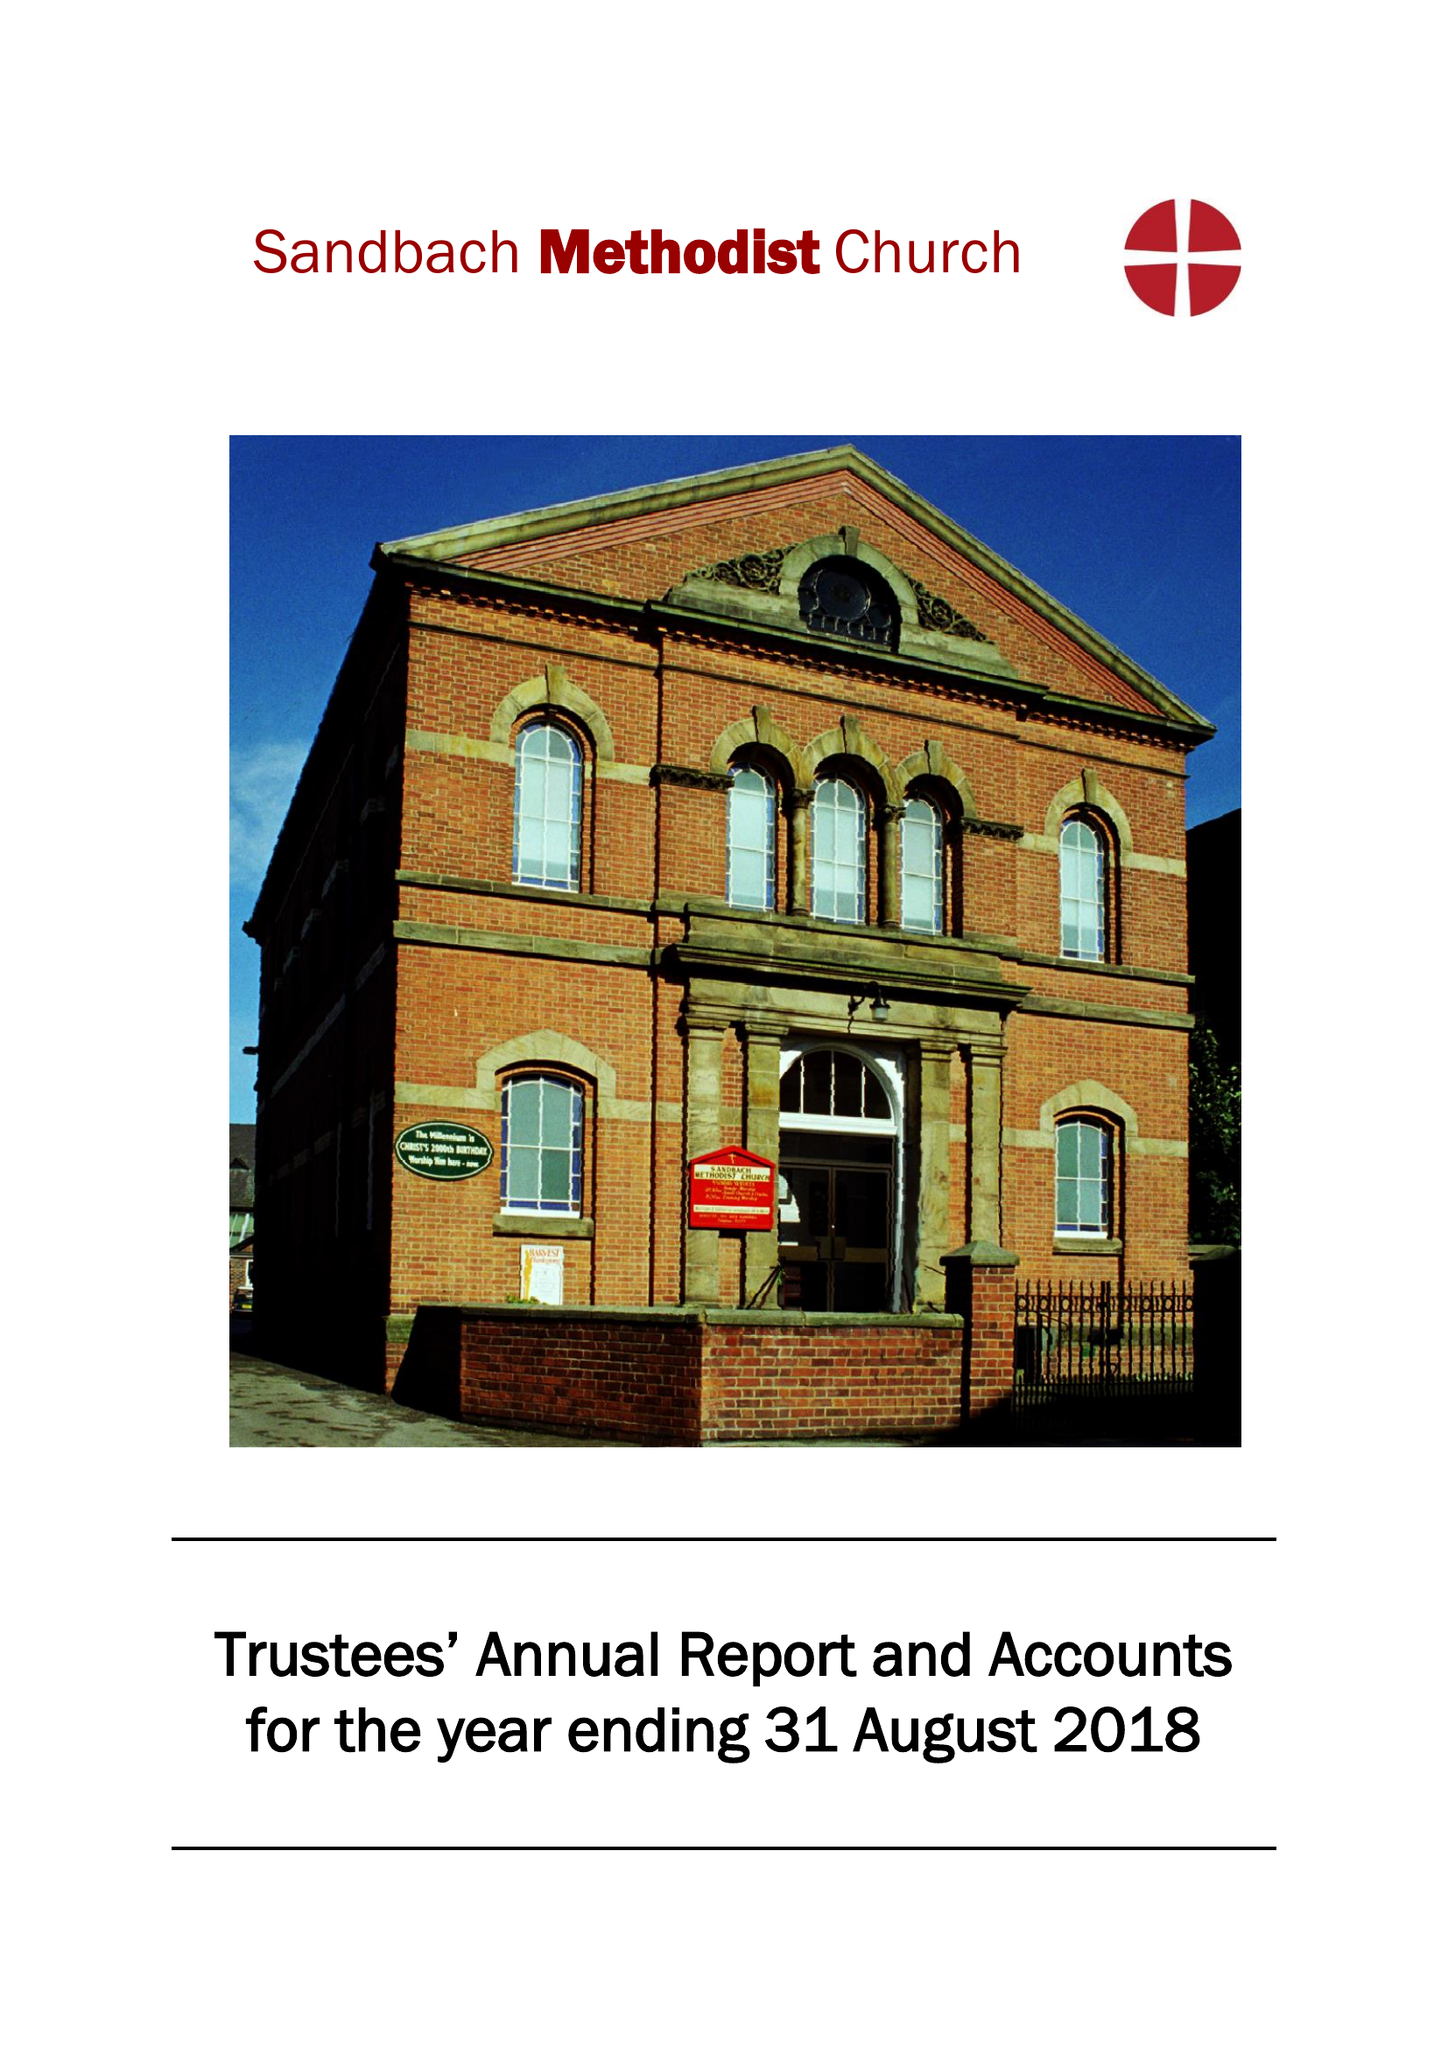What is the value for the address__post_town?
Answer the question using a single word or phrase. SANDBACH 